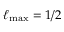Convert formula to latex. <formula><loc_0><loc_0><loc_500><loc_500>\ell _ { \max } = 1 / 2</formula> 